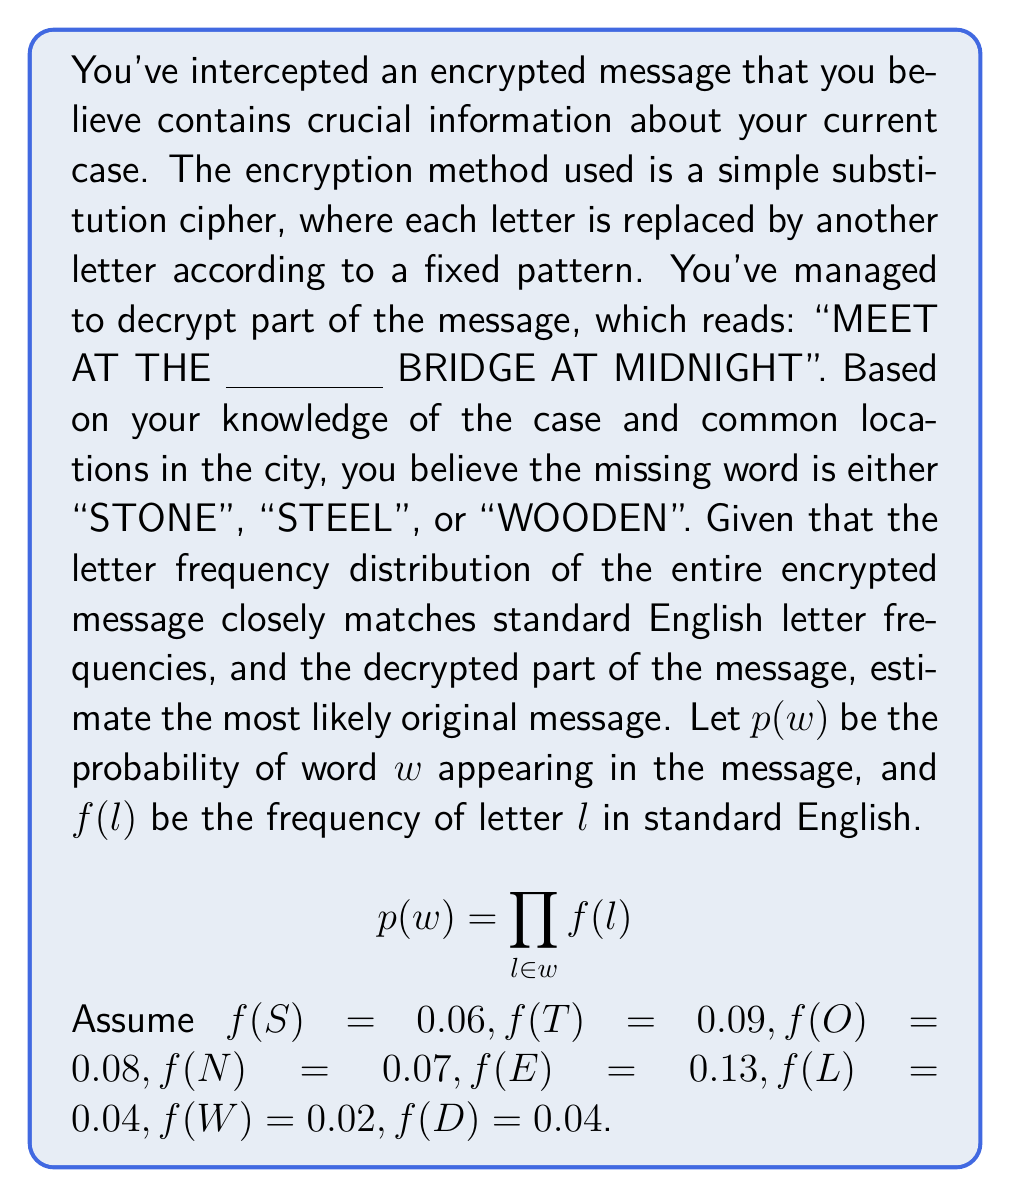Could you help me with this problem? To solve this problem, we need to calculate the probability of each possible word using the given formula and letter frequencies. The word with the highest probability is the most likely to be the original message.

1. Calculate $p("STONE")$:
   $$p("STONE") = f(S) \times f(T) \times f(O) \times f(N) \times f(E)$$
   $$p("STONE") = 0.06 \times 0.09 \times 0.08 \times 0.07 \times 0.13 = 2.95 \times 10^{-6}$$

2. Calculate $p("STEEL")$:
   $$p("STEEL") = f(S) \times f(T) \times f(E) \times f(E) \times f(L)$$
   $$p("STEEL") = 0.06 \times 0.09 \times 0.13 \times 0.13 \times 0.04 = 3.65 \times 10^{-6}$$

3. Calculate $p("WOODEN")$:
   $$p("WOODEN") = f(W) \times f(O) \times f(O) \times f(D) \times f(E) \times f(N)$$
   $$p("WOODEN") = 0.02 \times 0.08 \times 0.08 \times 0.04 \times 0.13 \times 0.07 = 5.38 \times 10^{-8}$$

4. Compare the probabilities:
   $p("STEEL") > p("STONE") > p("WOODEN")$

The word "STEEL" has the highest probability, so it is the most likely original message.
Answer: "MEET AT THE STEEL BRIDGE AT MIDNIGHT" 